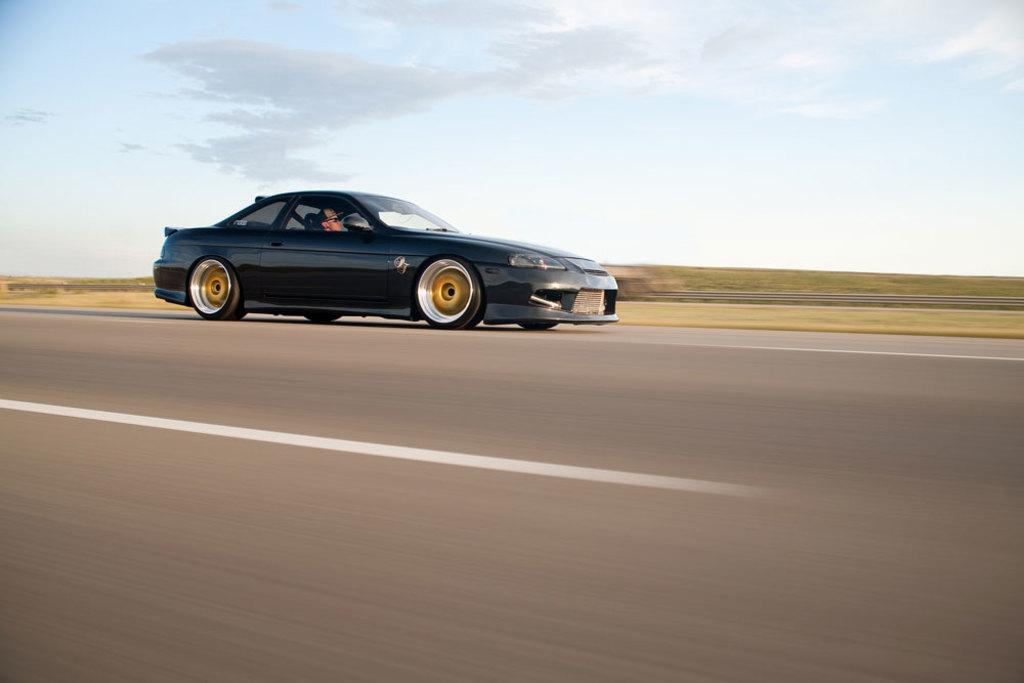What is in the foreground of the image? There is a road in the foreground of the image. What can be seen in the center of the image? There is a black car in the center of the image. How would you describe the background of the image? The background of the image is blurred. What part of the natural environment is visible in the image? The sky is visible in the image. How many eyes can be seen on the car in the image? There are no eyes visible on the car in the image, as cars do not have eyes. Is there a harbor depicted in the background of the image? There is no harbor present in the image; the background is blurred and only the sky is visible. 